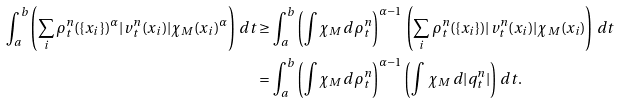Convert formula to latex. <formula><loc_0><loc_0><loc_500><loc_500>\int _ { a } ^ { b } \left ( \sum _ { i } \rho ^ { n } _ { t } ( \{ x _ { i } \} ) ^ { \alpha } | v ^ { n } _ { t } ( x _ { i } ) | \chi _ { M } ( x _ { i } ) ^ { \alpha } \right ) \, d t & \geq \int _ { a } ^ { b } \left ( \int \chi _ { M } \, d \rho ^ { n } _ { t } \right ) ^ { \alpha - 1 } \, \left ( \sum _ { i } \rho ^ { n } _ { t } ( \{ x _ { i } \} ) | v ^ { n } _ { t } ( x _ { i } ) | \chi _ { M } ( x _ { i } ) \right ) \, d t \\ & = \int _ { a } ^ { b } \left ( \int \chi _ { M } \, d \rho ^ { n } _ { t } \right ) ^ { \alpha - 1 } \left ( \int \, \chi _ { M } \, d | q ^ { n } _ { t } | \right ) \, d t .</formula> 